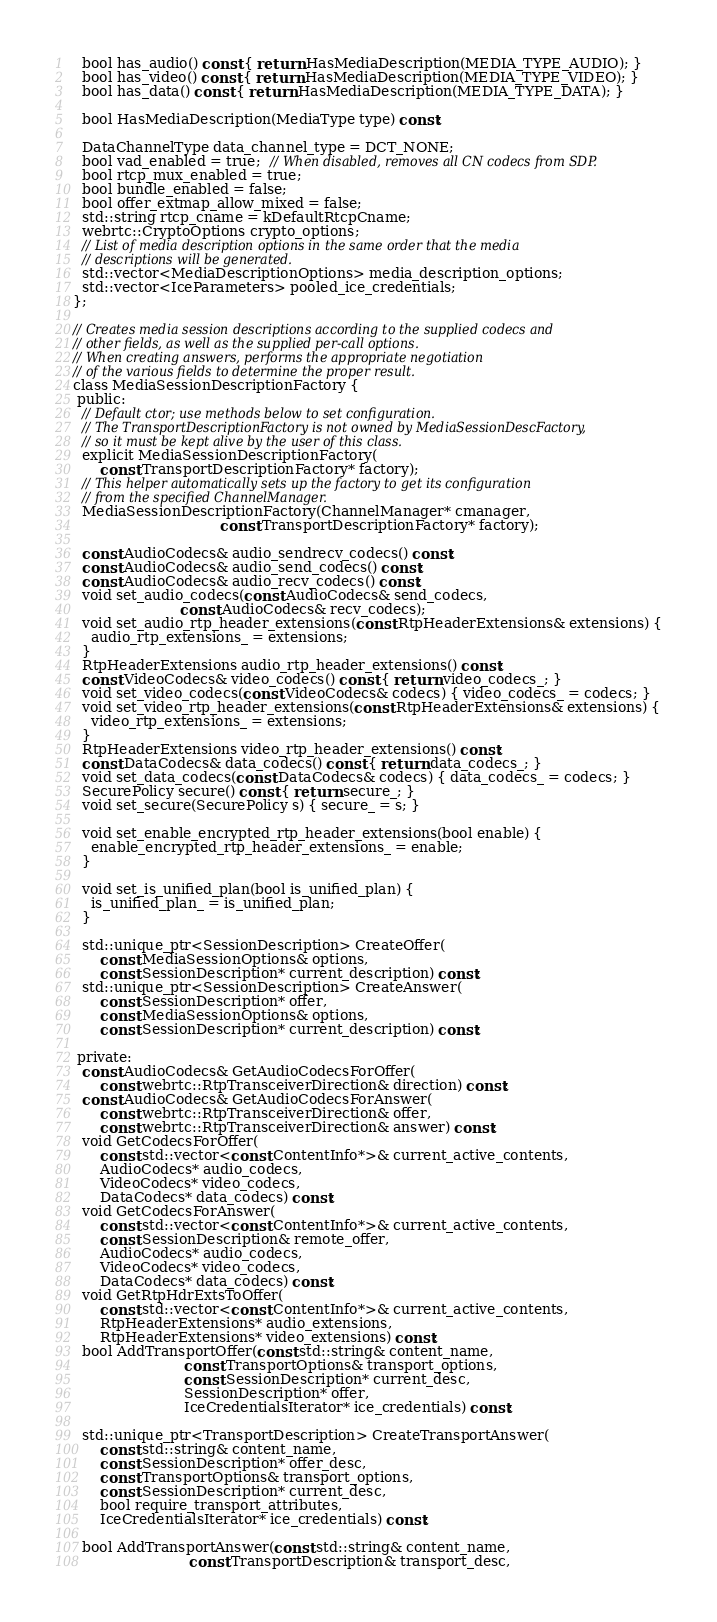Convert code to text. <code><loc_0><loc_0><loc_500><loc_500><_C_>
  bool has_audio() const { return HasMediaDescription(MEDIA_TYPE_AUDIO); }
  bool has_video() const { return HasMediaDescription(MEDIA_TYPE_VIDEO); }
  bool has_data() const { return HasMediaDescription(MEDIA_TYPE_DATA); }

  bool HasMediaDescription(MediaType type) const;

  DataChannelType data_channel_type = DCT_NONE;
  bool vad_enabled = true;  // When disabled, removes all CN codecs from SDP.
  bool rtcp_mux_enabled = true;
  bool bundle_enabled = false;
  bool offer_extmap_allow_mixed = false;
  std::string rtcp_cname = kDefaultRtcpCname;
  webrtc::CryptoOptions crypto_options;
  // List of media description options in the same order that the media
  // descriptions will be generated.
  std::vector<MediaDescriptionOptions> media_description_options;
  std::vector<IceParameters> pooled_ice_credentials;
};

// Creates media session descriptions according to the supplied codecs and
// other fields, as well as the supplied per-call options.
// When creating answers, performs the appropriate negotiation
// of the various fields to determine the proper result.
class MediaSessionDescriptionFactory {
 public:
  // Default ctor; use methods below to set configuration.
  // The TransportDescriptionFactory is not owned by MediaSessionDescFactory,
  // so it must be kept alive by the user of this class.
  explicit MediaSessionDescriptionFactory(
      const TransportDescriptionFactory* factory);
  // This helper automatically sets up the factory to get its configuration
  // from the specified ChannelManager.
  MediaSessionDescriptionFactory(ChannelManager* cmanager,
                                 const TransportDescriptionFactory* factory);

  const AudioCodecs& audio_sendrecv_codecs() const;
  const AudioCodecs& audio_send_codecs() const;
  const AudioCodecs& audio_recv_codecs() const;
  void set_audio_codecs(const AudioCodecs& send_codecs,
                        const AudioCodecs& recv_codecs);
  void set_audio_rtp_header_extensions(const RtpHeaderExtensions& extensions) {
    audio_rtp_extensions_ = extensions;
  }
  RtpHeaderExtensions audio_rtp_header_extensions() const;
  const VideoCodecs& video_codecs() const { return video_codecs_; }
  void set_video_codecs(const VideoCodecs& codecs) { video_codecs_ = codecs; }
  void set_video_rtp_header_extensions(const RtpHeaderExtensions& extensions) {
    video_rtp_extensions_ = extensions;
  }
  RtpHeaderExtensions video_rtp_header_extensions() const;
  const DataCodecs& data_codecs() const { return data_codecs_; }
  void set_data_codecs(const DataCodecs& codecs) { data_codecs_ = codecs; }
  SecurePolicy secure() const { return secure_; }
  void set_secure(SecurePolicy s) { secure_ = s; }

  void set_enable_encrypted_rtp_header_extensions(bool enable) {
    enable_encrypted_rtp_header_extensions_ = enable;
  }

  void set_is_unified_plan(bool is_unified_plan) {
    is_unified_plan_ = is_unified_plan;
  }

  std::unique_ptr<SessionDescription> CreateOffer(
      const MediaSessionOptions& options,
      const SessionDescription* current_description) const;
  std::unique_ptr<SessionDescription> CreateAnswer(
      const SessionDescription* offer,
      const MediaSessionOptions& options,
      const SessionDescription* current_description) const;

 private:
  const AudioCodecs& GetAudioCodecsForOffer(
      const webrtc::RtpTransceiverDirection& direction) const;
  const AudioCodecs& GetAudioCodecsForAnswer(
      const webrtc::RtpTransceiverDirection& offer,
      const webrtc::RtpTransceiverDirection& answer) const;
  void GetCodecsForOffer(
      const std::vector<const ContentInfo*>& current_active_contents,
      AudioCodecs* audio_codecs,
      VideoCodecs* video_codecs,
      DataCodecs* data_codecs) const;
  void GetCodecsForAnswer(
      const std::vector<const ContentInfo*>& current_active_contents,
      const SessionDescription& remote_offer,
      AudioCodecs* audio_codecs,
      VideoCodecs* video_codecs,
      DataCodecs* data_codecs) const;
  void GetRtpHdrExtsToOffer(
      const std::vector<const ContentInfo*>& current_active_contents,
      RtpHeaderExtensions* audio_extensions,
      RtpHeaderExtensions* video_extensions) const;
  bool AddTransportOffer(const std::string& content_name,
                         const TransportOptions& transport_options,
                         const SessionDescription* current_desc,
                         SessionDescription* offer,
                         IceCredentialsIterator* ice_credentials) const;

  std::unique_ptr<TransportDescription> CreateTransportAnswer(
      const std::string& content_name,
      const SessionDescription* offer_desc,
      const TransportOptions& transport_options,
      const SessionDescription* current_desc,
      bool require_transport_attributes,
      IceCredentialsIterator* ice_credentials) const;

  bool AddTransportAnswer(const std::string& content_name,
                          const TransportDescription& transport_desc,</code> 